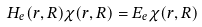<formula> <loc_0><loc_0><loc_500><loc_500>H _ { e } ( r , R ) \chi ( r , R ) = E _ { e } \chi ( r , R )</formula> 